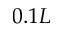<formula> <loc_0><loc_0><loc_500><loc_500>0 . 1 L</formula> 